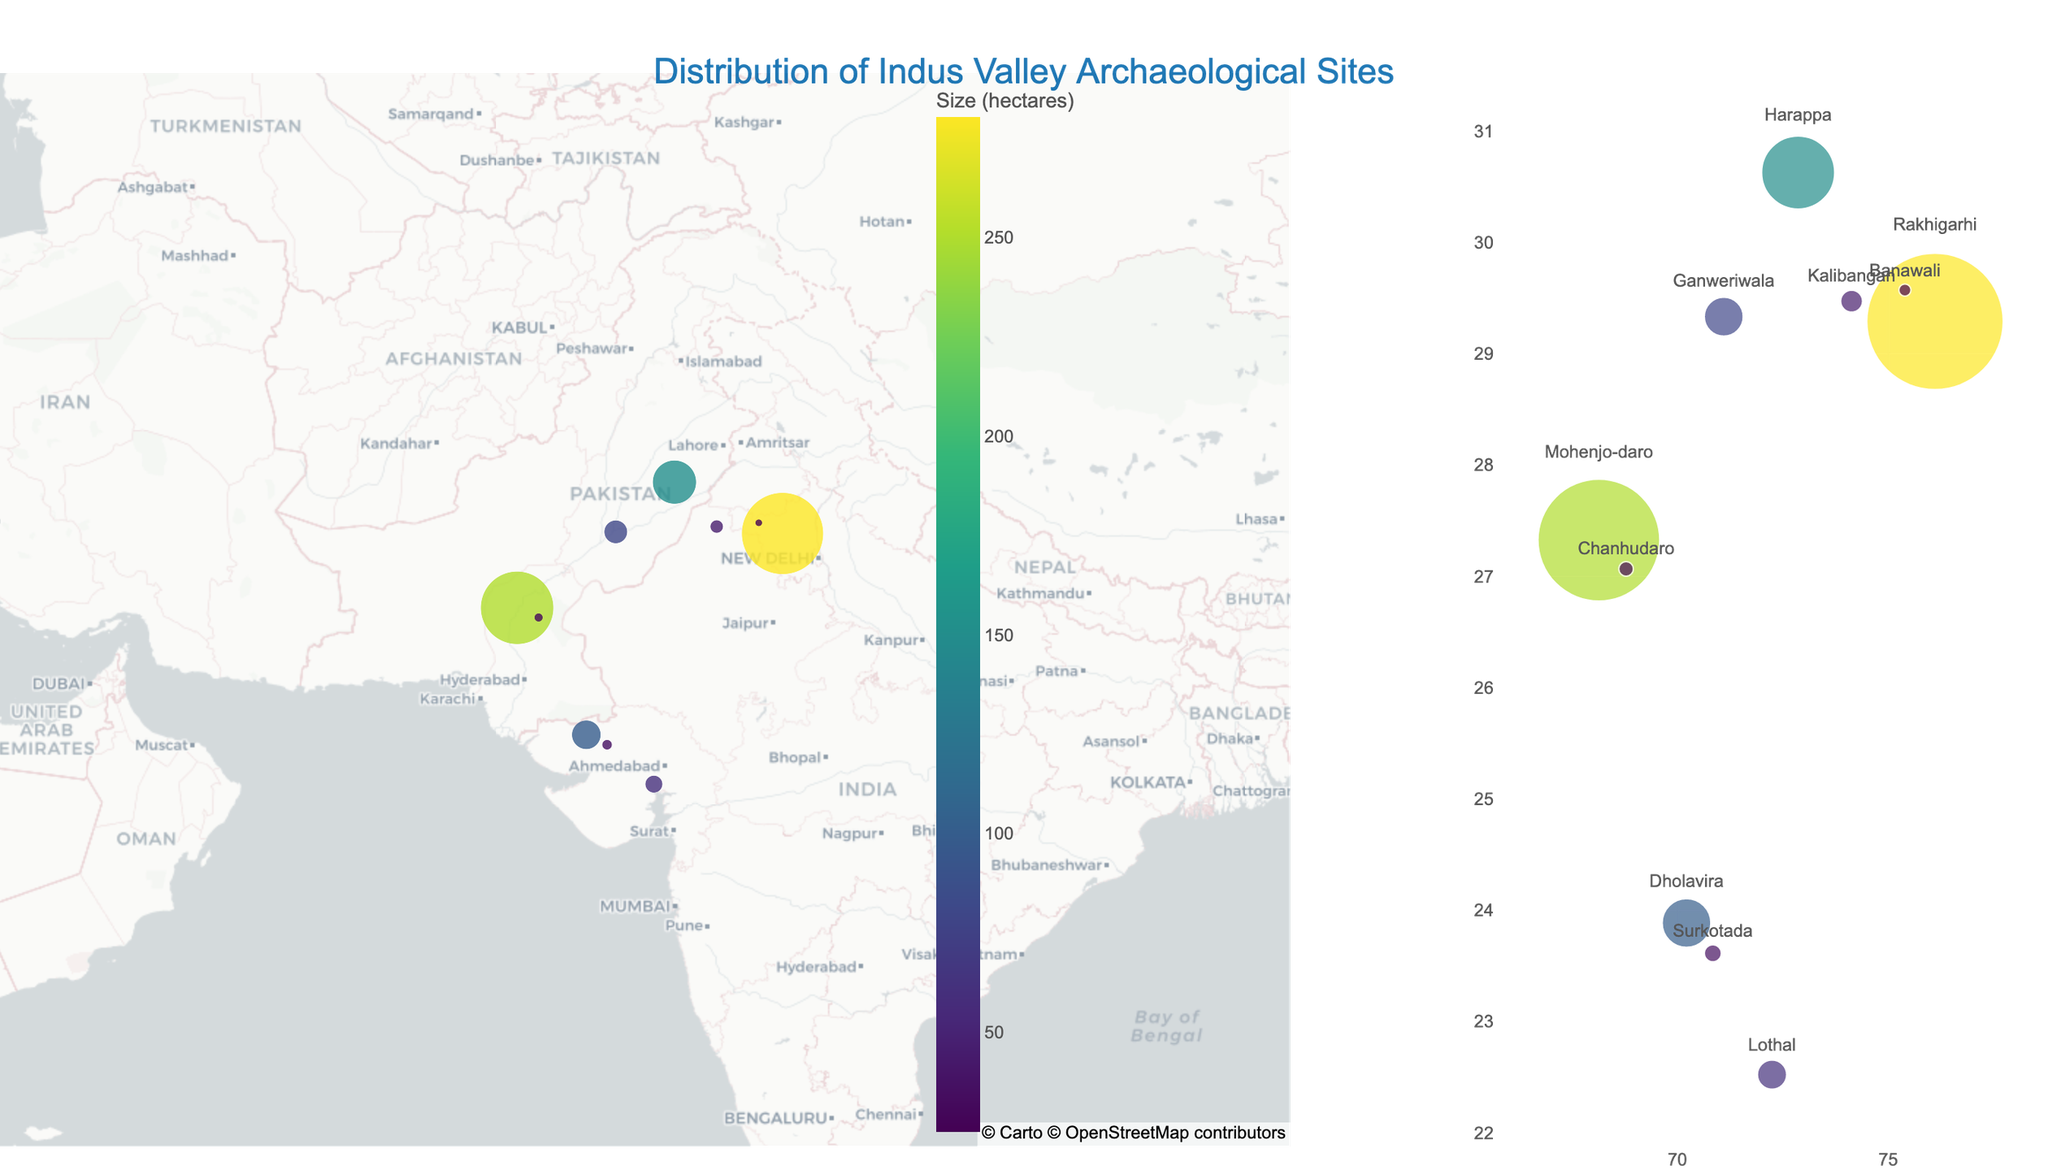What is the title of the figure? The title of the figure is usually displayed at the top and in a larger font. By looking at that part, the title can be read.
Answer: Distribution of Indus Valley Archaeological Sites Which site has the largest size in hectares? By looking at the data points on the map, the size of the sites is represented by the size of the markers. The largest marker corresponds to the largest site. Additionally, the hover information provides specific size details.
Answer: Rakhigarhi How many sites have a size of less than 50 hectares? By checking the sizes given in the data points, we can count the number of sites where the size is less than 50 hectares.
Answer: 4 What unique artifact is associated with Harappa? By looking at the hover information for Harappa on the map, the notable artifacts for each site are provided.
Answer: Unicorn Seal Which site is located furthest south on the map? By comparing the latitude values of all the sites, the site with the smallest latitude value is the one located furthest south.
Answer: Chanhudaro Which site is closest to the center of the map? The center of the map is calculated using the average latitude and longitude. By comparing the latitude and longitude of each site to these average values, the closest site can be determined.
Answer: Kalibangan What is the average size of all the sites in hectares? To find the average size, sum up the sizes of all the sites and then divide by the number of sites: (250 + 150 + 100 + 280 + 80 + 60 + 45 + 35 + 25 + 30) / 10.
Answer: 105.5 hectares What artifact is most commonly mentioned among the sites? By reviewing the notable artifacts listed for each site, we can see which artifact is mentioned the most often. In this case, since every artifact is unique, none is repeated more than once.
Answer: None (all unique) How does the distribution of site sizes compare between northern and southern sites? By mentally or visually dividing the map into northern and southern halves and comparing the sizes (using marker sizes and hover information) of the sites in each region.
Answer: Northern sites generally have larger sizes than southern sites What is the relationship between the size of the site and the color of its marker? The color of the marker on the map is scaled according to the size of the site using a colorscale (Viridis). Thus, larger sites are represented with colors towards the higher end of the scale.
Answer: Larger sites have darker colors 